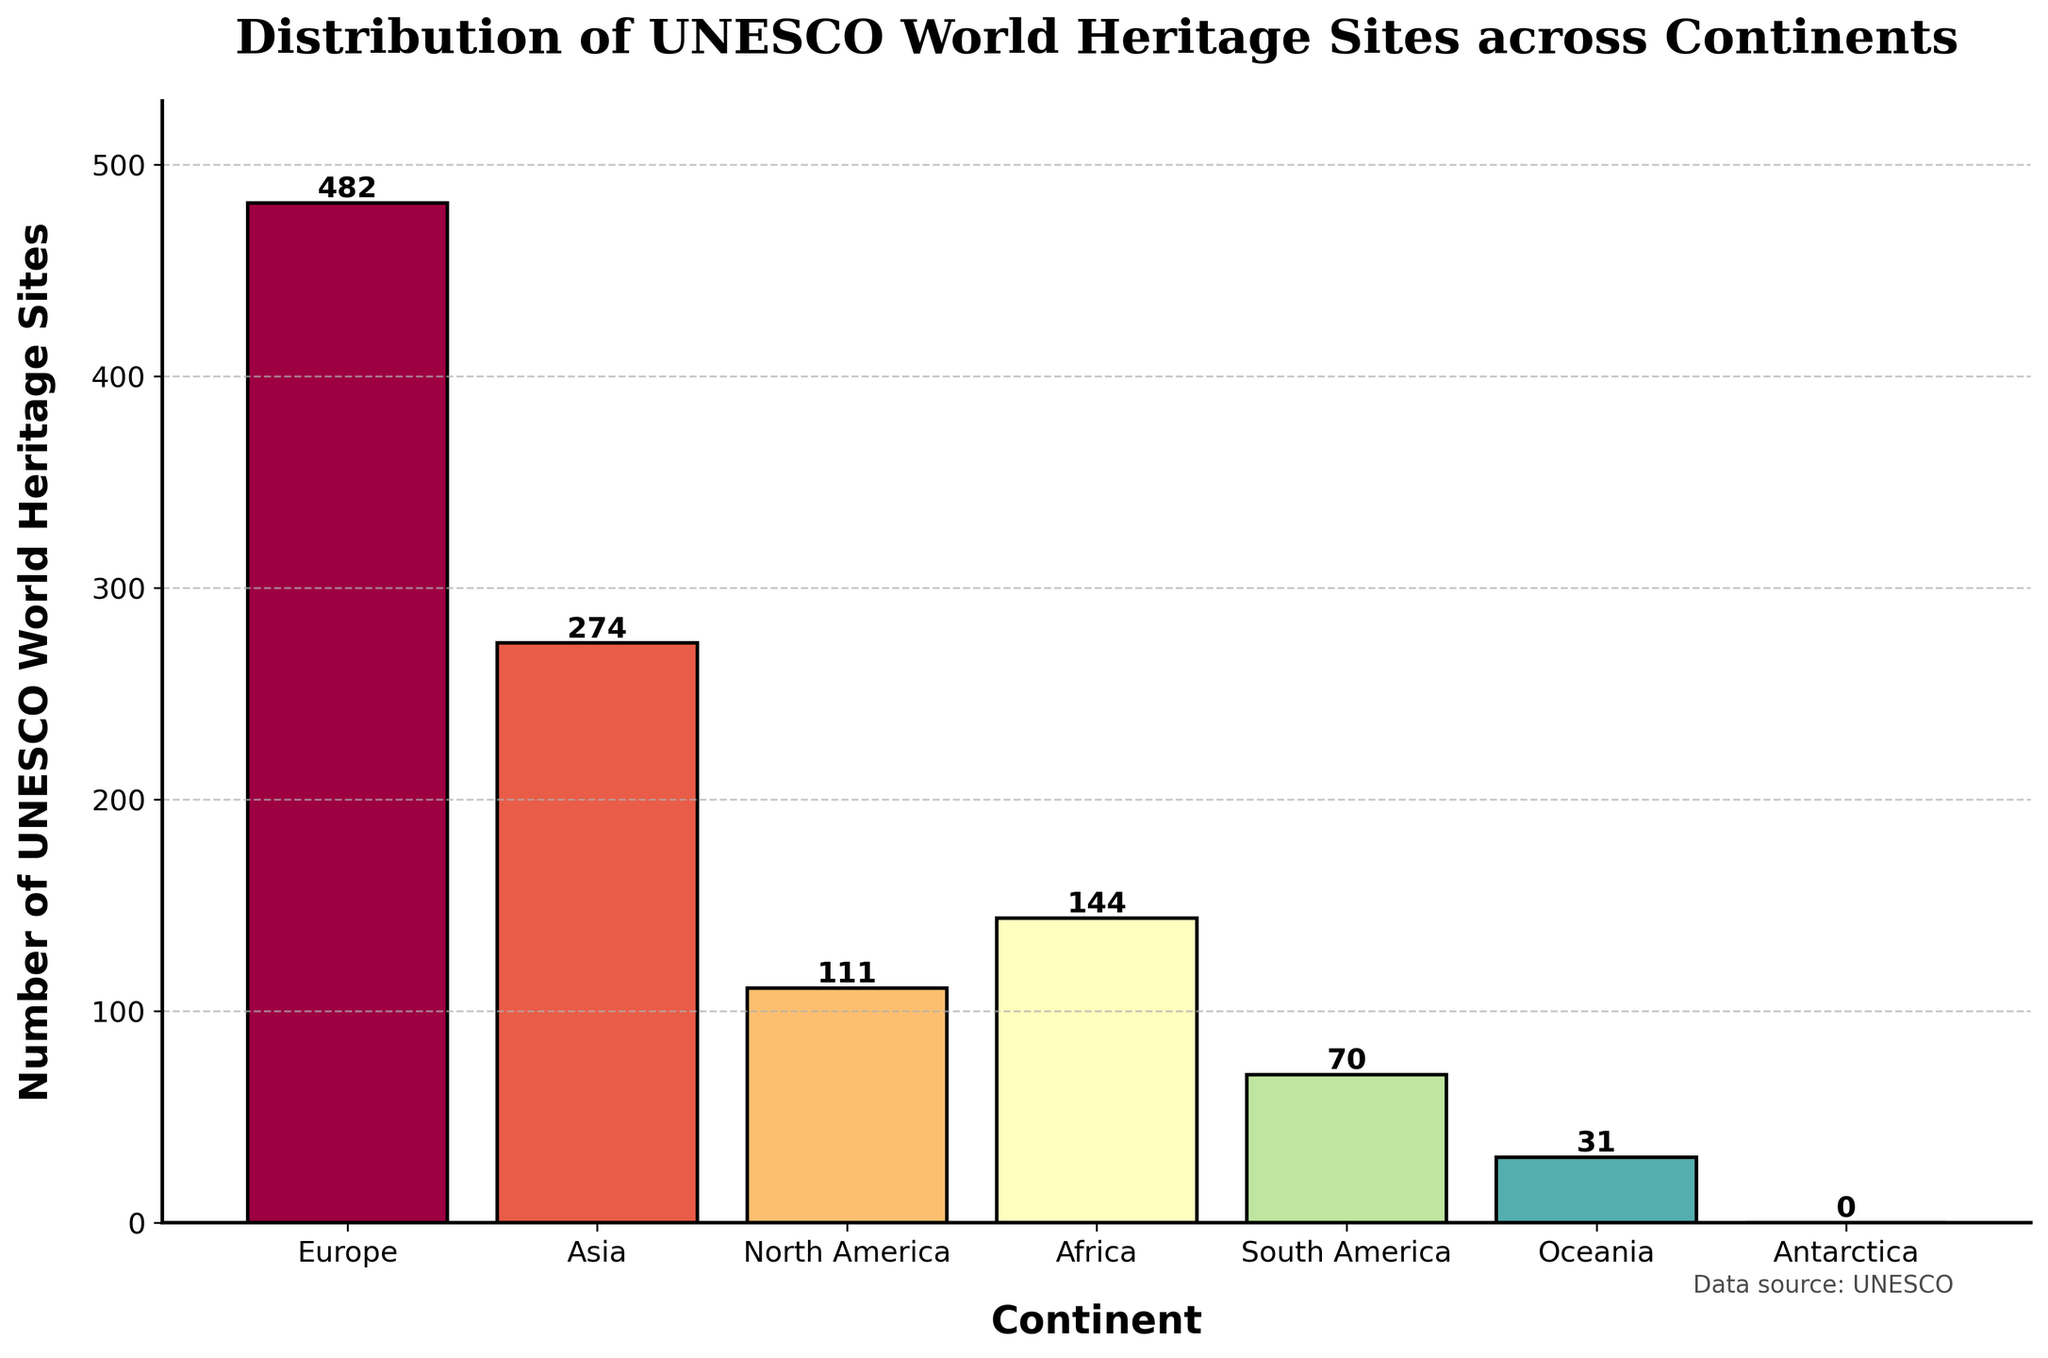Which continent has the highest number of UNESCO World Heritage Sites? The tallest bar in the figure represents the continent with the highest number of sites. Here, it is Europe.
Answer: Europe How many more UNESCO World Heritage Sites does Europe have than South America? Europe has 482 sites and South America has 70. The difference is 482 - 70.
Answer: 412 What is the total number of UNESCO World Heritage Sites in Africa and Oceania combined? Africa has 144 sites and Oceania has 31. The total is 144 + 31.
Answer: 175 Which continents have fewer than 100 UNESCO World Heritage Sites? By inspecting the heights of the bars, South America (70), Oceania (31), and Antarctica (0) all have fewer than 100 sites.
Answer: South America, Oceania, Antarctica What is the average number of UNESCO World Heritage Sites per continent (excluding Antarctica)? There are 6 continents with sites: Europe (482), Asia (274), North America (111), Africa (144), South America (70), and Oceania (31). The total is 1112. The average is 1112 / 6.
Answer: 185.33 Which continent's bar is colored the most dramatically different compared to the others? The colors of the bars represent different continents uniquely. The bar that stands out the most in terms of color can be judged visually from the figure.
Answer: Response would be subjective and vary What is the height of the bar for North America relative to that for Asia? The height of the bar for North America is 111; for Asia, it is 274. North America's bar is shorter.
Answer: Shorter Which continents have a bar height within 50 units of Africa's? Africa has 144 sites. Look for bars within the range of 94 to 194. North America (111) fits this criterion.
Answer: North America How many continents have over 200 UNESCO World Heritage Sites? By inspecting the figure, Europe (482) and Asia (274) have more than 200 sites.
Answer: 2 